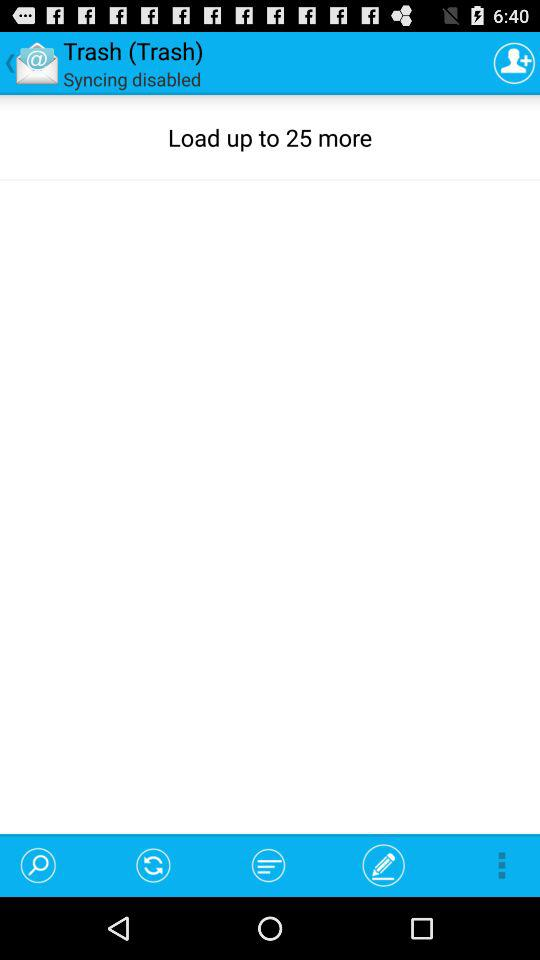What is the sync status?
Answer the question using a single word or phrase. It is disabled. 